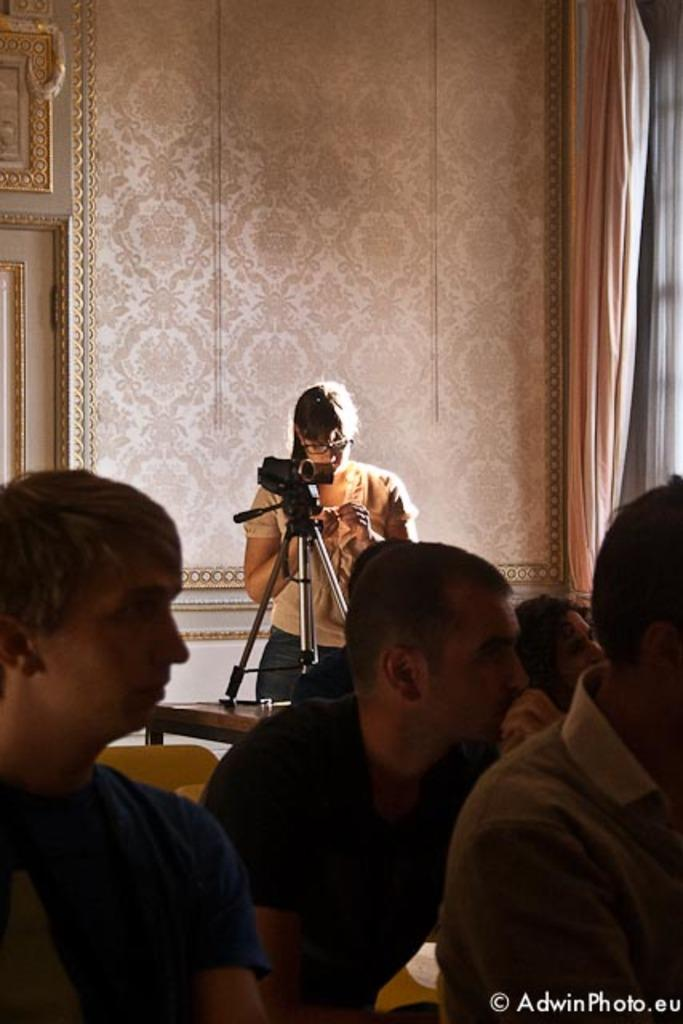What is the main subject of the image? The main subject of the image is a group of men. What are the men doing in the image? The men are sitting in the image. Is there anyone else in the image besides the group of men? Yes, there is a woman in the image. What is the woman holding in the image? The woman is holding a camera in the image. What can be seen in the background of the image? There is a wall in the image, and there is a curtain on the right side of the image. What is the rate of the board falling in the image? There is no board or falling action present in the image. 